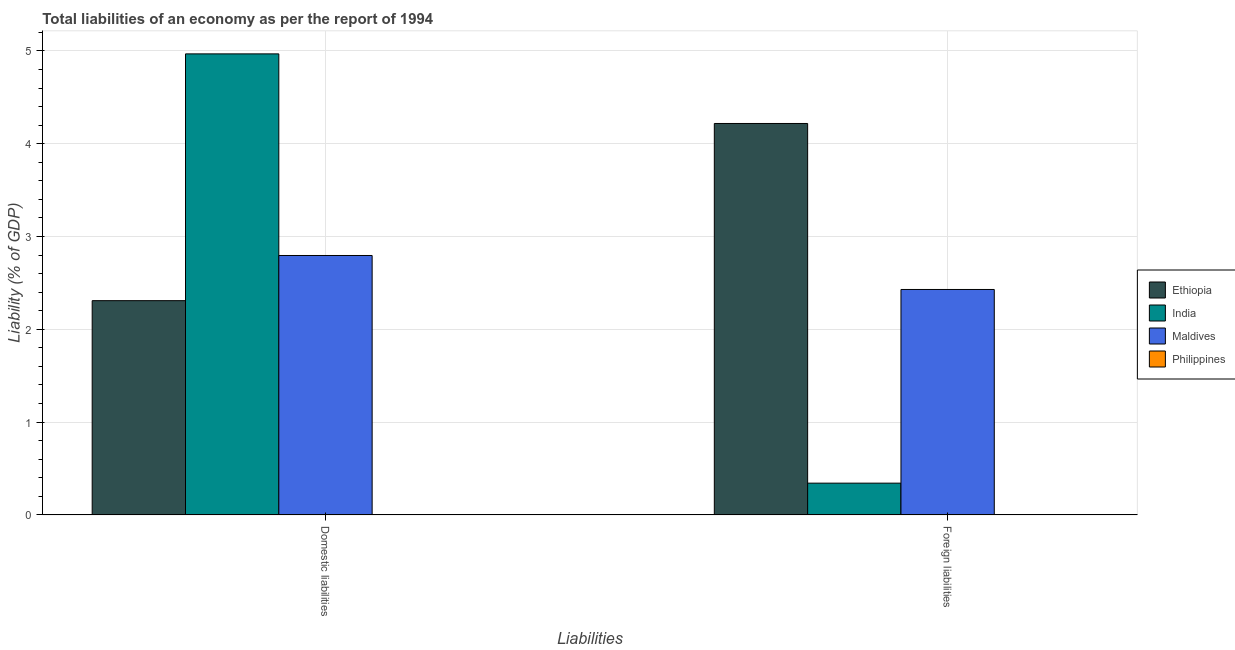How many groups of bars are there?
Provide a succinct answer. 2. Are the number of bars per tick equal to the number of legend labels?
Provide a short and direct response. No. Are the number of bars on each tick of the X-axis equal?
Your answer should be very brief. Yes. How many bars are there on the 2nd tick from the left?
Your answer should be compact. 3. How many bars are there on the 2nd tick from the right?
Keep it short and to the point. 3. What is the label of the 1st group of bars from the left?
Your answer should be compact. Domestic liabilities. What is the incurrence of foreign liabilities in Ethiopia?
Offer a terse response. 4.22. Across all countries, what is the maximum incurrence of foreign liabilities?
Offer a terse response. 4.22. In which country was the incurrence of foreign liabilities maximum?
Your answer should be compact. Ethiopia. What is the total incurrence of domestic liabilities in the graph?
Provide a short and direct response. 10.07. What is the difference between the incurrence of domestic liabilities in Maldives and that in India?
Offer a very short reply. -2.17. What is the difference between the incurrence of domestic liabilities in Maldives and the incurrence of foreign liabilities in Philippines?
Give a very brief answer. 2.8. What is the average incurrence of foreign liabilities per country?
Offer a very short reply. 1.75. What is the difference between the incurrence of foreign liabilities and incurrence of domestic liabilities in India?
Keep it short and to the point. -4.63. In how many countries, is the incurrence of foreign liabilities greater than 1.4 %?
Give a very brief answer. 2. What is the ratio of the incurrence of foreign liabilities in India to that in Maldives?
Your answer should be very brief. 0.14. How many bars are there?
Keep it short and to the point. 6. Are all the bars in the graph horizontal?
Offer a very short reply. No. Does the graph contain any zero values?
Your response must be concise. Yes. Does the graph contain grids?
Your response must be concise. Yes. Where does the legend appear in the graph?
Your answer should be very brief. Center right. What is the title of the graph?
Offer a very short reply. Total liabilities of an economy as per the report of 1994. Does "Aruba" appear as one of the legend labels in the graph?
Keep it short and to the point. No. What is the label or title of the X-axis?
Offer a terse response. Liabilities. What is the label or title of the Y-axis?
Provide a succinct answer. Liability (% of GDP). What is the Liability (% of GDP) in Ethiopia in Domestic liabilities?
Your response must be concise. 2.31. What is the Liability (% of GDP) in India in Domestic liabilities?
Keep it short and to the point. 4.97. What is the Liability (% of GDP) of Maldives in Domestic liabilities?
Offer a very short reply. 2.8. What is the Liability (% of GDP) of Philippines in Domestic liabilities?
Ensure brevity in your answer.  0. What is the Liability (% of GDP) in Ethiopia in Foreign liabilities?
Give a very brief answer. 4.22. What is the Liability (% of GDP) of India in Foreign liabilities?
Give a very brief answer. 0.34. What is the Liability (% of GDP) of Maldives in Foreign liabilities?
Give a very brief answer. 2.43. What is the Liability (% of GDP) in Philippines in Foreign liabilities?
Provide a short and direct response. 0. Across all Liabilities, what is the maximum Liability (% of GDP) of Ethiopia?
Ensure brevity in your answer.  4.22. Across all Liabilities, what is the maximum Liability (% of GDP) in India?
Provide a succinct answer. 4.97. Across all Liabilities, what is the maximum Liability (% of GDP) in Maldives?
Give a very brief answer. 2.8. Across all Liabilities, what is the minimum Liability (% of GDP) of Ethiopia?
Provide a short and direct response. 2.31. Across all Liabilities, what is the minimum Liability (% of GDP) of India?
Make the answer very short. 0.34. Across all Liabilities, what is the minimum Liability (% of GDP) in Maldives?
Your answer should be compact. 2.43. What is the total Liability (% of GDP) in Ethiopia in the graph?
Make the answer very short. 6.53. What is the total Liability (% of GDP) of India in the graph?
Keep it short and to the point. 5.31. What is the total Liability (% of GDP) in Maldives in the graph?
Provide a succinct answer. 5.22. What is the difference between the Liability (% of GDP) of Ethiopia in Domestic liabilities and that in Foreign liabilities?
Ensure brevity in your answer.  -1.91. What is the difference between the Liability (% of GDP) of India in Domestic liabilities and that in Foreign liabilities?
Ensure brevity in your answer.  4.63. What is the difference between the Liability (% of GDP) in Maldives in Domestic liabilities and that in Foreign liabilities?
Offer a terse response. 0.37. What is the difference between the Liability (% of GDP) of Ethiopia in Domestic liabilities and the Liability (% of GDP) of India in Foreign liabilities?
Provide a short and direct response. 1.97. What is the difference between the Liability (% of GDP) in Ethiopia in Domestic liabilities and the Liability (% of GDP) in Maldives in Foreign liabilities?
Provide a short and direct response. -0.12. What is the difference between the Liability (% of GDP) in India in Domestic liabilities and the Liability (% of GDP) in Maldives in Foreign liabilities?
Ensure brevity in your answer.  2.54. What is the average Liability (% of GDP) of Ethiopia per Liabilities?
Offer a very short reply. 3.26. What is the average Liability (% of GDP) of India per Liabilities?
Ensure brevity in your answer.  2.66. What is the average Liability (% of GDP) of Maldives per Liabilities?
Make the answer very short. 2.61. What is the average Liability (% of GDP) of Philippines per Liabilities?
Provide a short and direct response. 0. What is the difference between the Liability (% of GDP) of Ethiopia and Liability (% of GDP) of India in Domestic liabilities?
Ensure brevity in your answer.  -2.66. What is the difference between the Liability (% of GDP) of Ethiopia and Liability (% of GDP) of Maldives in Domestic liabilities?
Offer a very short reply. -0.49. What is the difference between the Liability (% of GDP) in India and Liability (% of GDP) in Maldives in Domestic liabilities?
Your response must be concise. 2.17. What is the difference between the Liability (% of GDP) in Ethiopia and Liability (% of GDP) in India in Foreign liabilities?
Ensure brevity in your answer.  3.88. What is the difference between the Liability (% of GDP) in Ethiopia and Liability (% of GDP) in Maldives in Foreign liabilities?
Make the answer very short. 1.79. What is the difference between the Liability (% of GDP) in India and Liability (% of GDP) in Maldives in Foreign liabilities?
Provide a short and direct response. -2.09. What is the ratio of the Liability (% of GDP) in Ethiopia in Domestic liabilities to that in Foreign liabilities?
Make the answer very short. 0.55. What is the ratio of the Liability (% of GDP) of India in Domestic liabilities to that in Foreign liabilities?
Provide a short and direct response. 14.51. What is the ratio of the Liability (% of GDP) in Maldives in Domestic liabilities to that in Foreign liabilities?
Provide a succinct answer. 1.15. What is the difference between the highest and the second highest Liability (% of GDP) in Ethiopia?
Make the answer very short. 1.91. What is the difference between the highest and the second highest Liability (% of GDP) in India?
Your response must be concise. 4.63. What is the difference between the highest and the second highest Liability (% of GDP) of Maldives?
Offer a very short reply. 0.37. What is the difference between the highest and the lowest Liability (% of GDP) in Ethiopia?
Your answer should be compact. 1.91. What is the difference between the highest and the lowest Liability (% of GDP) of India?
Offer a terse response. 4.63. What is the difference between the highest and the lowest Liability (% of GDP) of Maldives?
Keep it short and to the point. 0.37. 